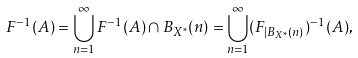<formula> <loc_0><loc_0><loc_500><loc_500>F ^ { - 1 } ( A ) = \bigcup _ { n = 1 } ^ { \infty } F ^ { - 1 } ( A ) \cap B _ { X ^ { \ast } } ( n ) = \bigcup _ { n = 1 } ^ { \infty } ( F _ { | B _ { X ^ { \ast } } ( n ) } ) ^ { - 1 } ( A ) ,</formula> 